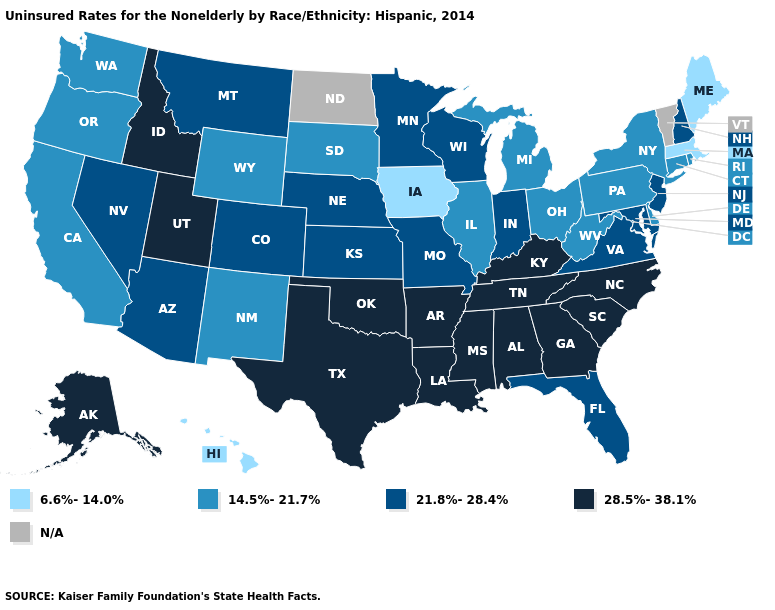Does Massachusetts have the highest value in the USA?
Be succinct. No. What is the lowest value in the USA?
Write a very short answer. 6.6%-14.0%. Does Montana have the highest value in the USA?
Concise answer only. No. What is the value of Vermont?
Short answer required. N/A. What is the value of Idaho?
Write a very short answer. 28.5%-38.1%. What is the highest value in the USA?
Quick response, please. 28.5%-38.1%. Among the states that border North Dakota , does Minnesota have the lowest value?
Answer briefly. No. What is the value of Delaware?
Be succinct. 14.5%-21.7%. What is the value of Ohio?
Answer briefly. 14.5%-21.7%. What is the value of Maine?
Keep it brief. 6.6%-14.0%. Name the states that have a value in the range 21.8%-28.4%?
Give a very brief answer. Arizona, Colorado, Florida, Indiana, Kansas, Maryland, Minnesota, Missouri, Montana, Nebraska, Nevada, New Hampshire, New Jersey, Virginia, Wisconsin. Name the states that have a value in the range 21.8%-28.4%?
Concise answer only. Arizona, Colorado, Florida, Indiana, Kansas, Maryland, Minnesota, Missouri, Montana, Nebraska, Nevada, New Hampshire, New Jersey, Virginia, Wisconsin. What is the lowest value in states that border Mississippi?
Give a very brief answer. 28.5%-38.1%. 